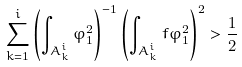<formula> <loc_0><loc_0><loc_500><loc_500>\sum _ { k = 1 } ^ { i } \left ( \int _ { A _ { k } ^ { i } } \varphi _ { 1 } ^ { 2 } \right ) ^ { - 1 } \left ( \int _ { A _ { k } ^ { i } } f \varphi _ { 1 } ^ { 2 } \right ) ^ { 2 } > \frac { 1 } { 2 }</formula> 